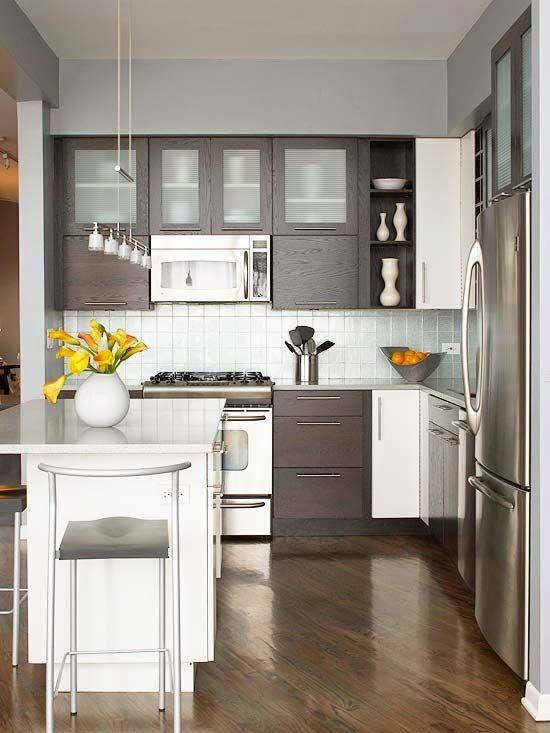Discuss the implications of having a small dining setup in this kitchen. The presence of a small island with a single stool in this kitchen implies a preference for compact and possibly solitary dining experiences. This setup might indicate that the resident either lives alone, prefers quick and informal meals, or possibly entertains on a minimal scale. It represents a practical and space-efficient approach to dining, offering a solution for fast-paced lifestyles where large, traditional meals around a big table are less common. Additionally, this setup could be reflective of a functional mindset, where space utilization is maximized without sacrificing aesthetic appeal. 